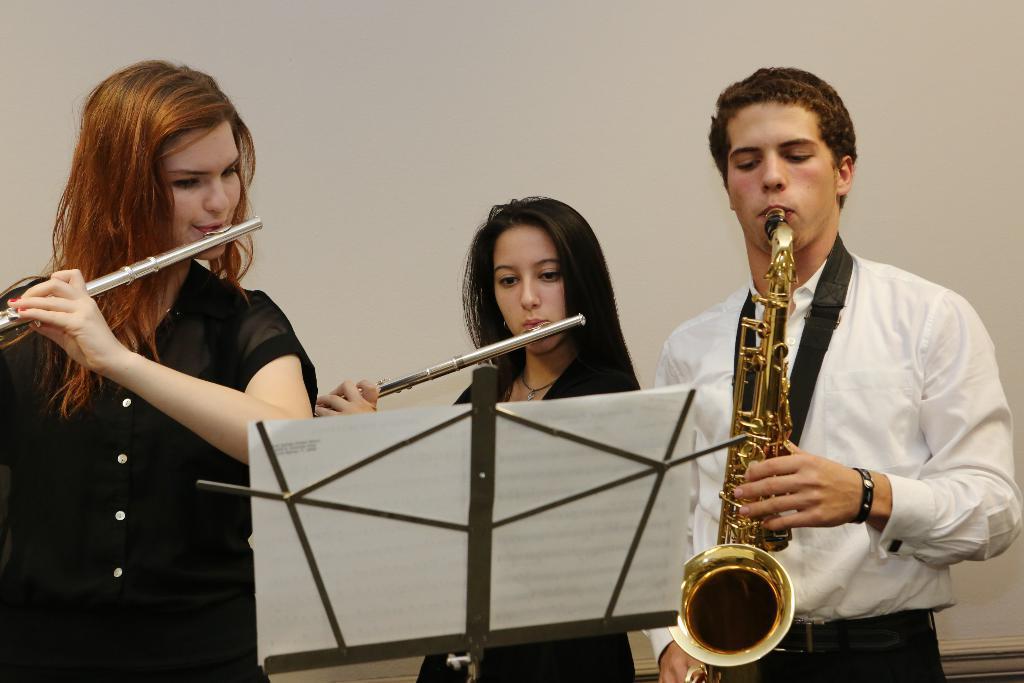Describe this image in one or two sentences. In this image there are three persons playing musical instruments, there are papers on the stand, the background of the image is white in color. 